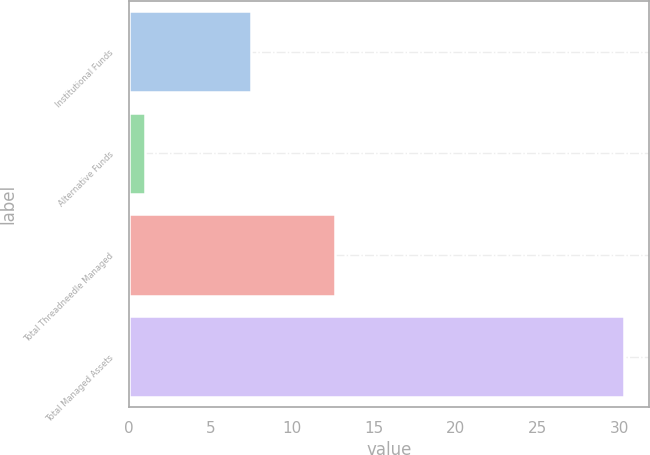<chart> <loc_0><loc_0><loc_500><loc_500><bar_chart><fcel>Institutional Funds<fcel>Alternative Funds<fcel>Total Threadneedle Managed<fcel>Total Managed Assets<nl><fcel>7.5<fcel>1<fcel>12.6<fcel>30.3<nl></chart> 